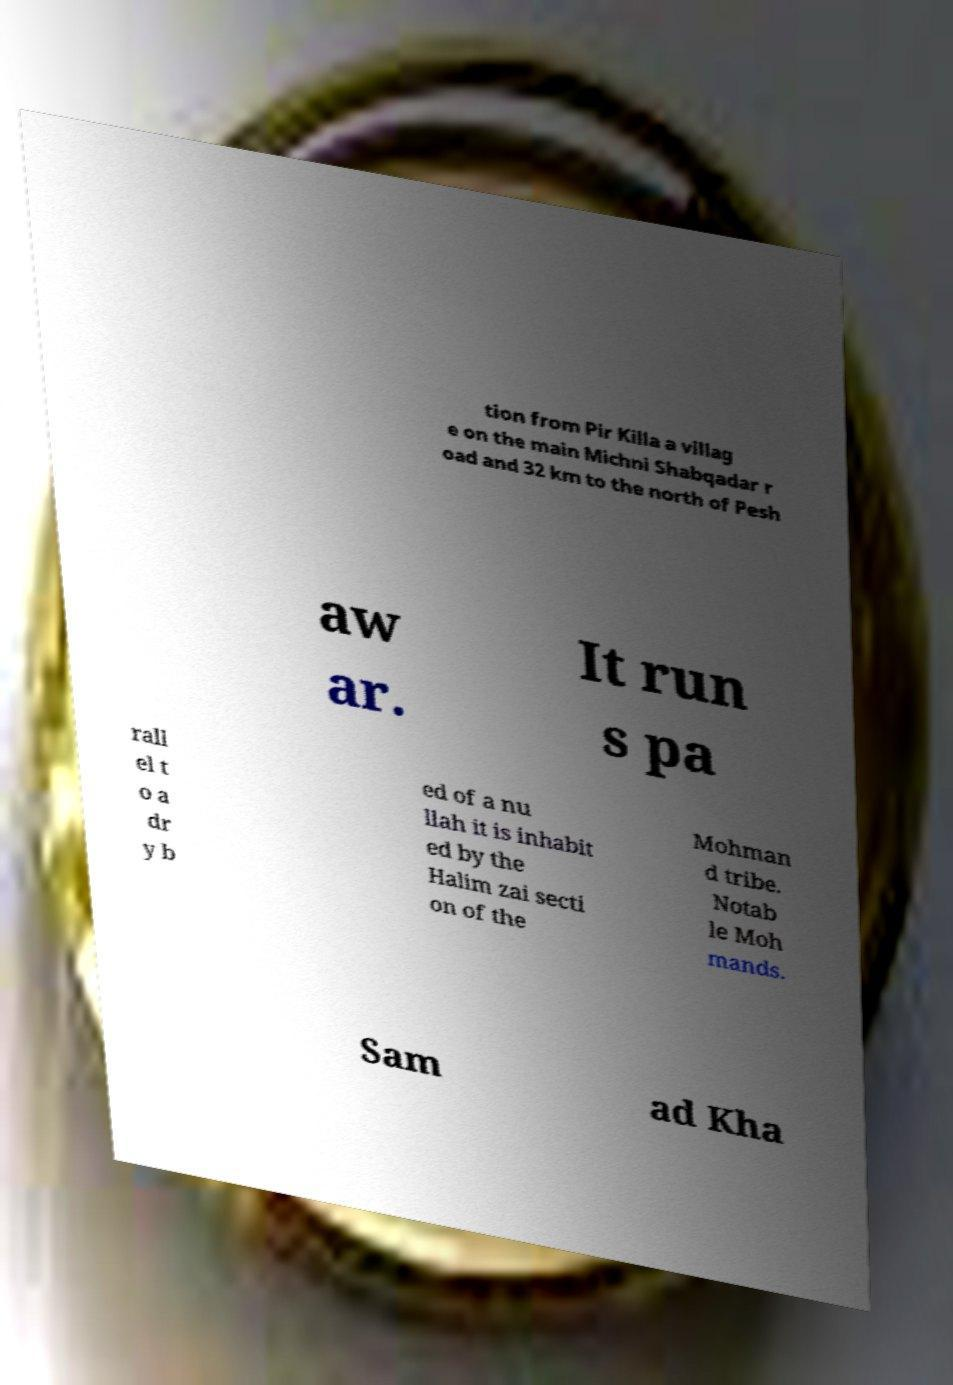Can you accurately transcribe the text from the provided image for me? tion from Pir Killa a villag e on the main Michni Shabqadar r oad and 32 km to the north of Pesh aw ar. It run s pa rall el t o a dr y b ed of a nu llah it is inhabit ed by the Halim zai secti on of the Mohman d tribe. Notab le Moh mands. Sam ad Kha 